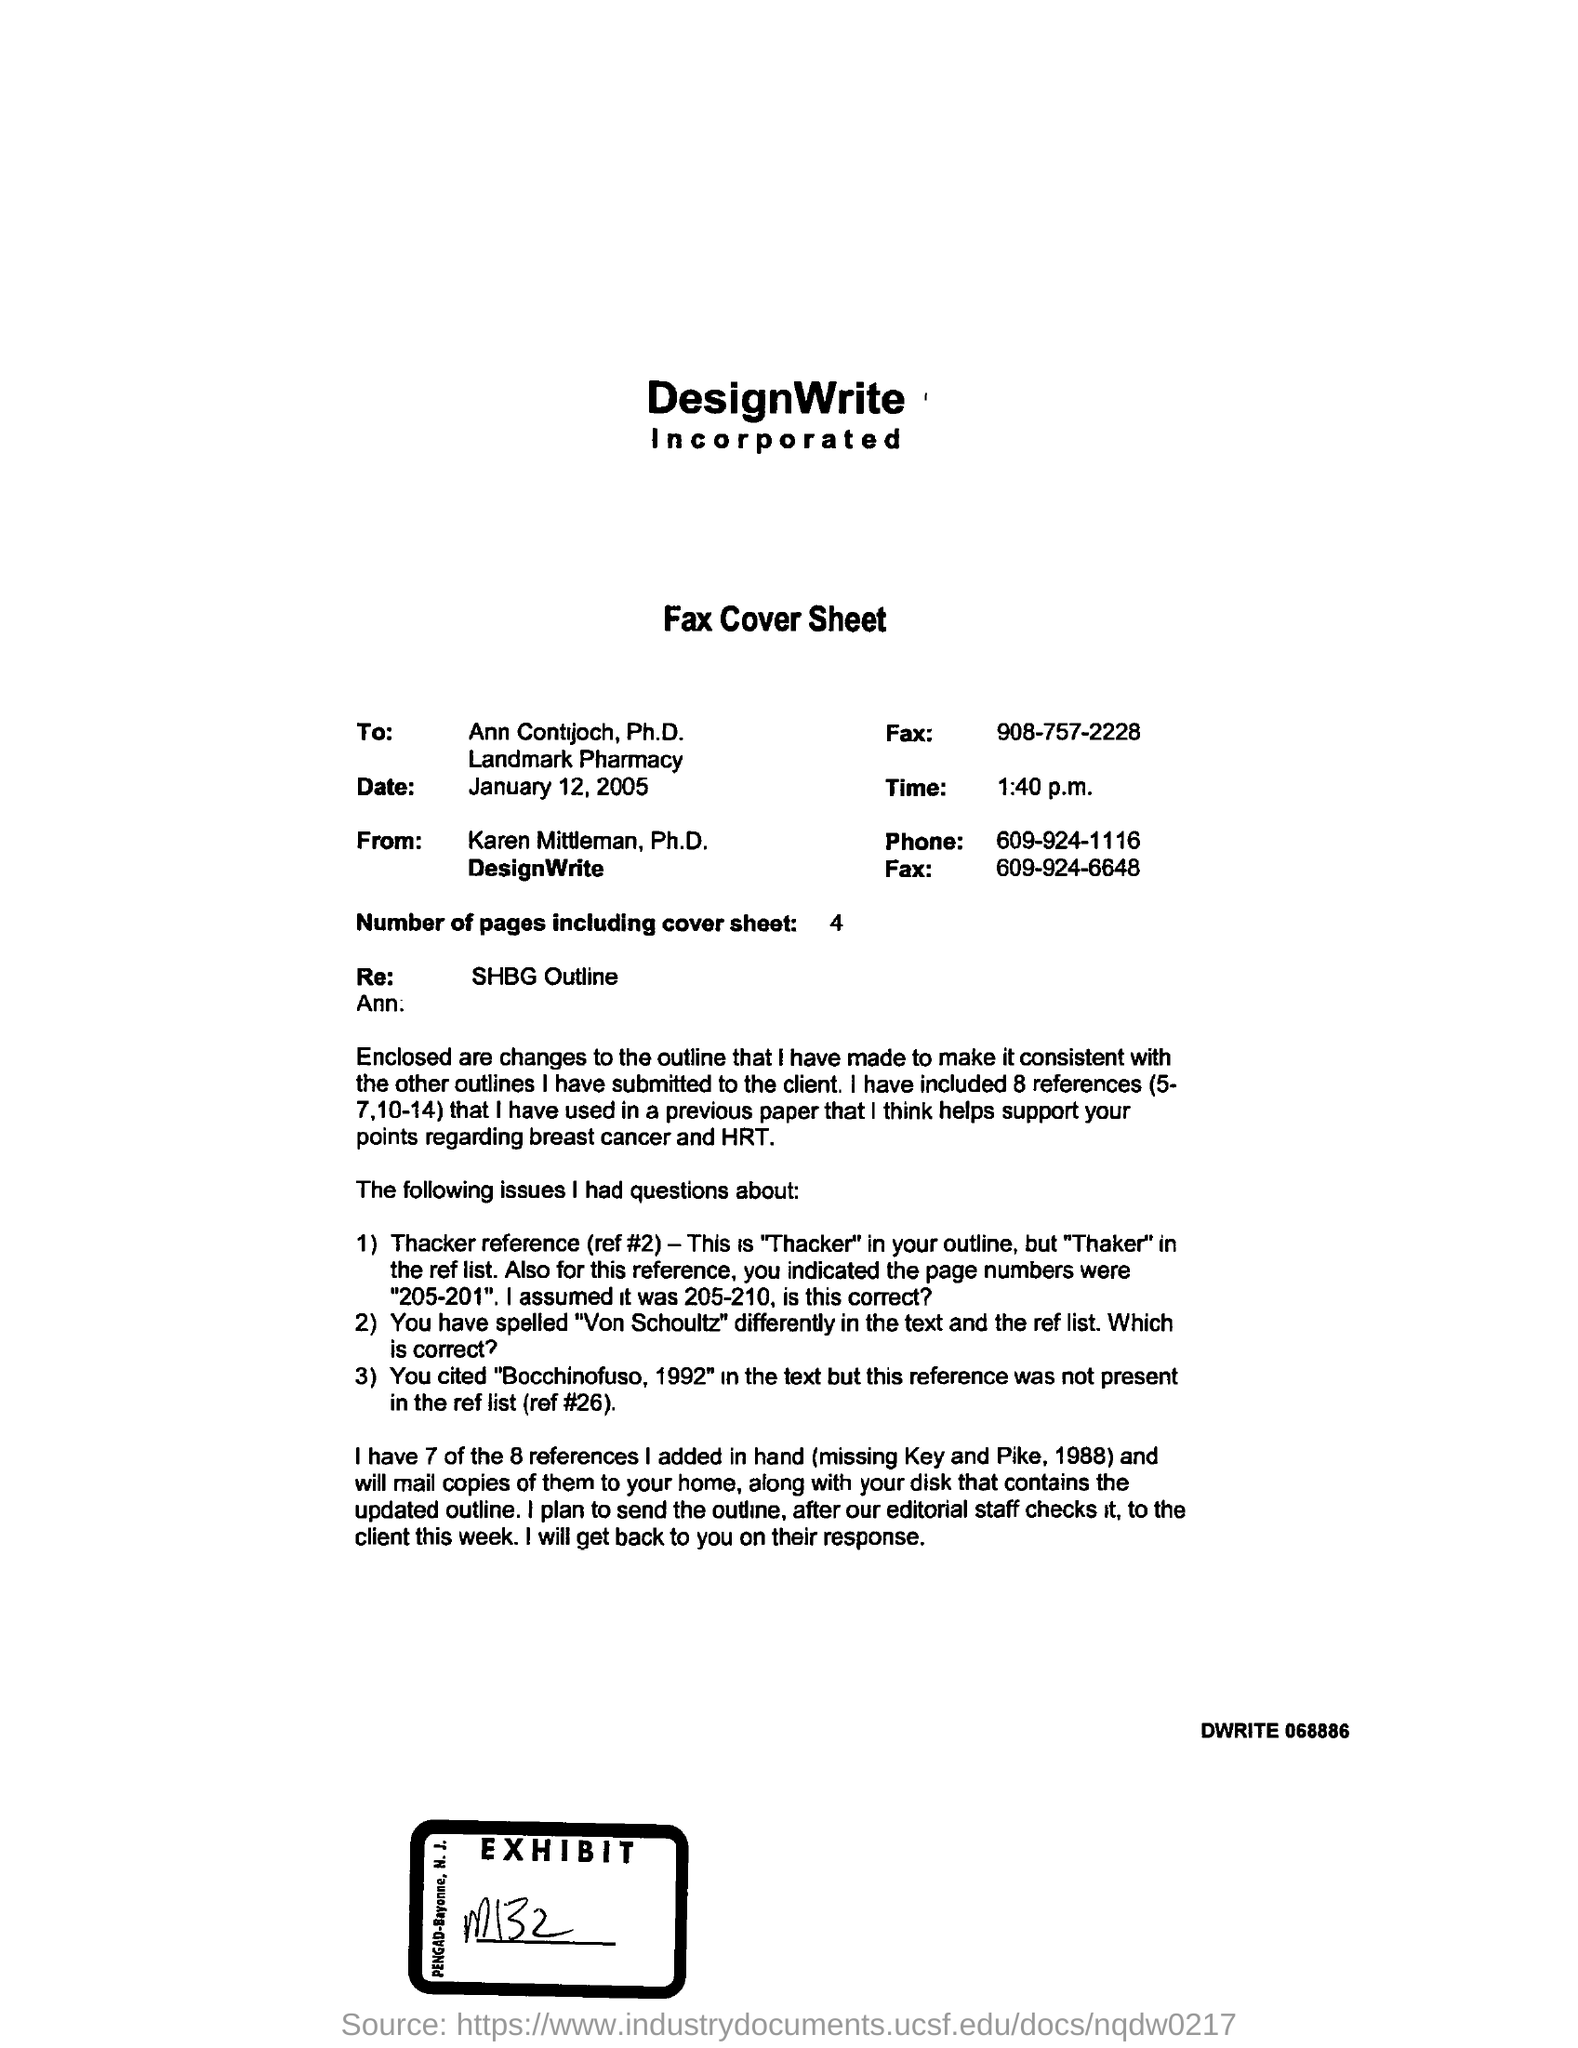Time at which fax cover sheet was sent?
Ensure brevity in your answer.  1:40 p.m. 